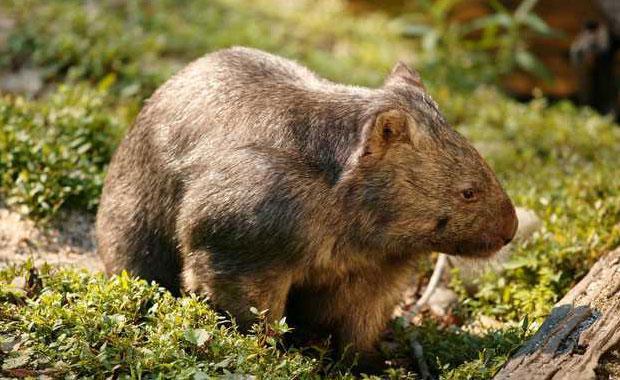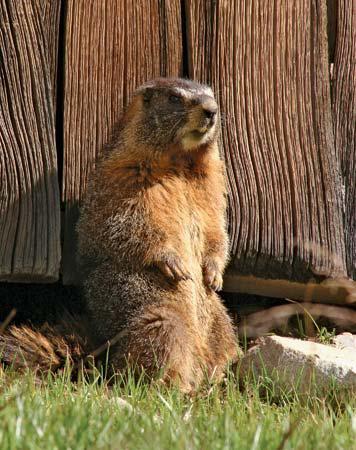The first image is the image on the left, the second image is the image on the right. Considering the images on both sides, is "There is a groundhog-like animal standing straight up with its paws in the air." valid? Answer yes or no. Yes. 